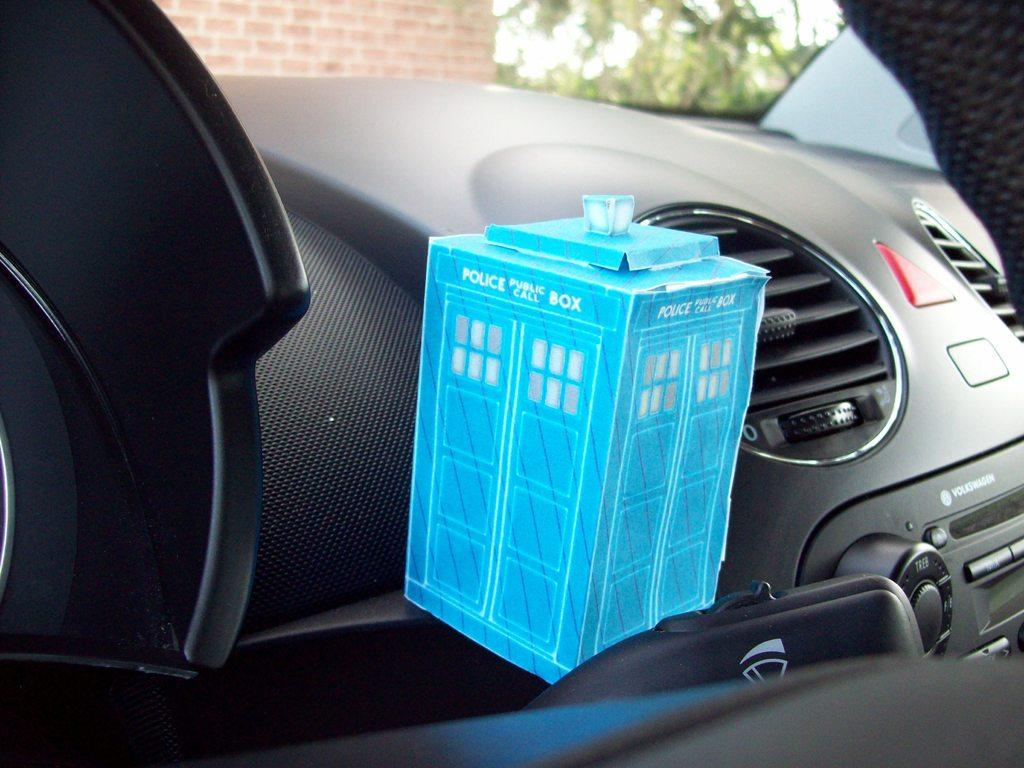What is the setting of the image? The image is an inside view of a car. What object can be seen in the middle of the image? There is a blue color box in the middle of the image. How much does the blue color box cost in the image? The image does not provide any information about the cost of the blue color box, as it is not a product or item for sale. 